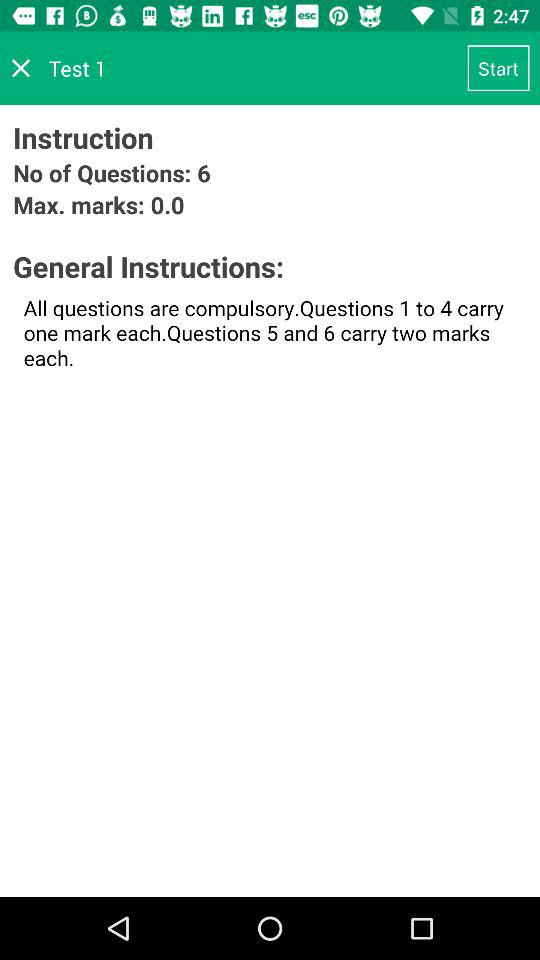How many more marks are available for questions 5 and 6 than for questions 1 to 4?
Answer the question using a single word or phrase. 1 